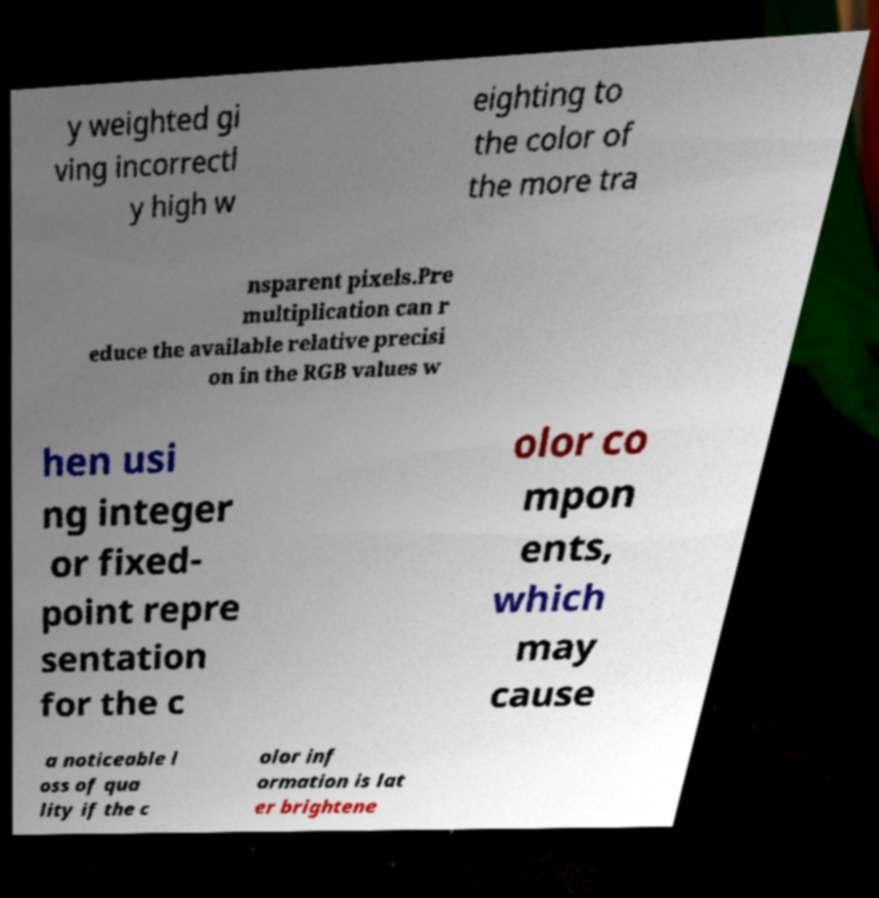Could you extract and type out the text from this image? y weighted gi ving incorrectl y high w eighting to the color of the more tra nsparent pixels.Pre multiplication can r educe the available relative precisi on in the RGB values w hen usi ng integer or fixed- point repre sentation for the c olor co mpon ents, which may cause a noticeable l oss of qua lity if the c olor inf ormation is lat er brightene 